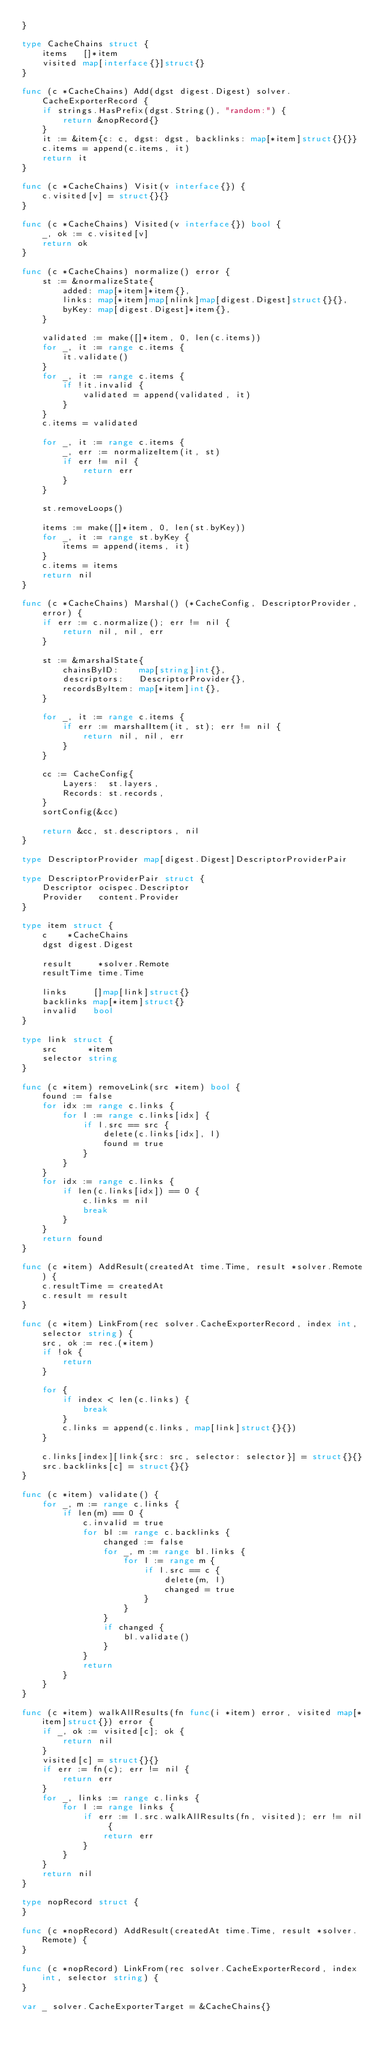Convert code to text. <code><loc_0><loc_0><loc_500><loc_500><_Go_>}

type CacheChains struct {
	items   []*item
	visited map[interface{}]struct{}
}

func (c *CacheChains) Add(dgst digest.Digest) solver.CacheExporterRecord {
	if strings.HasPrefix(dgst.String(), "random:") {
		return &nopRecord{}
	}
	it := &item{c: c, dgst: dgst, backlinks: map[*item]struct{}{}}
	c.items = append(c.items, it)
	return it
}

func (c *CacheChains) Visit(v interface{}) {
	c.visited[v] = struct{}{}
}

func (c *CacheChains) Visited(v interface{}) bool {
	_, ok := c.visited[v]
	return ok
}

func (c *CacheChains) normalize() error {
	st := &normalizeState{
		added: map[*item]*item{},
		links: map[*item]map[nlink]map[digest.Digest]struct{}{},
		byKey: map[digest.Digest]*item{},
	}

	validated := make([]*item, 0, len(c.items))
	for _, it := range c.items {
		it.validate()
	}
	for _, it := range c.items {
		if !it.invalid {
			validated = append(validated, it)
		}
	}
	c.items = validated

	for _, it := range c.items {
		_, err := normalizeItem(it, st)
		if err != nil {
			return err
		}
	}

	st.removeLoops()

	items := make([]*item, 0, len(st.byKey))
	for _, it := range st.byKey {
		items = append(items, it)
	}
	c.items = items
	return nil
}

func (c *CacheChains) Marshal() (*CacheConfig, DescriptorProvider, error) {
	if err := c.normalize(); err != nil {
		return nil, nil, err
	}

	st := &marshalState{
		chainsByID:    map[string]int{},
		descriptors:   DescriptorProvider{},
		recordsByItem: map[*item]int{},
	}

	for _, it := range c.items {
		if err := marshalItem(it, st); err != nil {
			return nil, nil, err
		}
	}

	cc := CacheConfig{
		Layers:  st.layers,
		Records: st.records,
	}
	sortConfig(&cc)

	return &cc, st.descriptors, nil
}

type DescriptorProvider map[digest.Digest]DescriptorProviderPair

type DescriptorProviderPair struct {
	Descriptor ocispec.Descriptor
	Provider   content.Provider
}

type item struct {
	c    *CacheChains
	dgst digest.Digest

	result     *solver.Remote
	resultTime time.Time

	links     []map[link]struct{}
	backlinks map[*item]struct{}
	invalid   bool
}

type link struct {
	src      *item
	selector string
}

func (c *item) removeLink(src *item) bool {
	found := false
	for idx := range c.links {
		for l := range c.links[idx] {
			if l.src == src {
				delete(c.links[idx], l)
				found = true
			}
		}
	}
	for idx := range c.links {
		if len(c.links[idx]) == 0 {
			c.links = nil
			break
		}
	}
	return found
}

func (c *item) AddResult(createdAt time.Time, result *solver.Remote) {
	c.resultTime = createdAt
	c.result = result
}

func (c *item) LinkFrom(rec solver.CacheExporterRecord, index int, selector string) {
	src, ok := rec.(*item)
	if !ok {
		return
	}

	for {
		if index < len(c.links) {
			break
		}
		c.links = append(c.links, map[link]struct{}{})
	}

	c.links[index][link{src: src, selector: selector}] = struct{}{}
	src.backlinks[c] = struct{}{}
}

func (c *item) validate() {
	for _, m := range c.links {
		if len(m) == 0 {
			c.invalid = true
			for bl := range c.backlinks {
				changed := false
				for _, m := range bl.links {
					for l := range m {
						if l.src == c {
							delete(m, l)
							changed = true
						}
					}
				}
				if changed {
					bl.validate()
				}
			}
			return
		}
	}
}

func (c *item) walkAllResults(fn func(i *item) error, visited map[*item]struct{}) error {
	if _, ok := visited[c]; ok {
		return nil
	}
	visited[c] = struct{}{}
	if err := fn(c); err != nil {
		return err
	}
	for _, links := range c.links {
		for l := range links {
			if err := l.src.walkAllResults(fn, visited); err != nil {
				return err
			}
		}
	}
	return nil
}

type nopRecord struct {
}

func (c *nopRecord) AddResult(createdAt time.Time, result *solver.Remote) {
}

func (c *nopRecord) LinkFrom(rec solver.CacheExporterRecord, index int, selector string) {
}

var _ solver.CacheExporterTarget = &CacheChains{}
</code> 